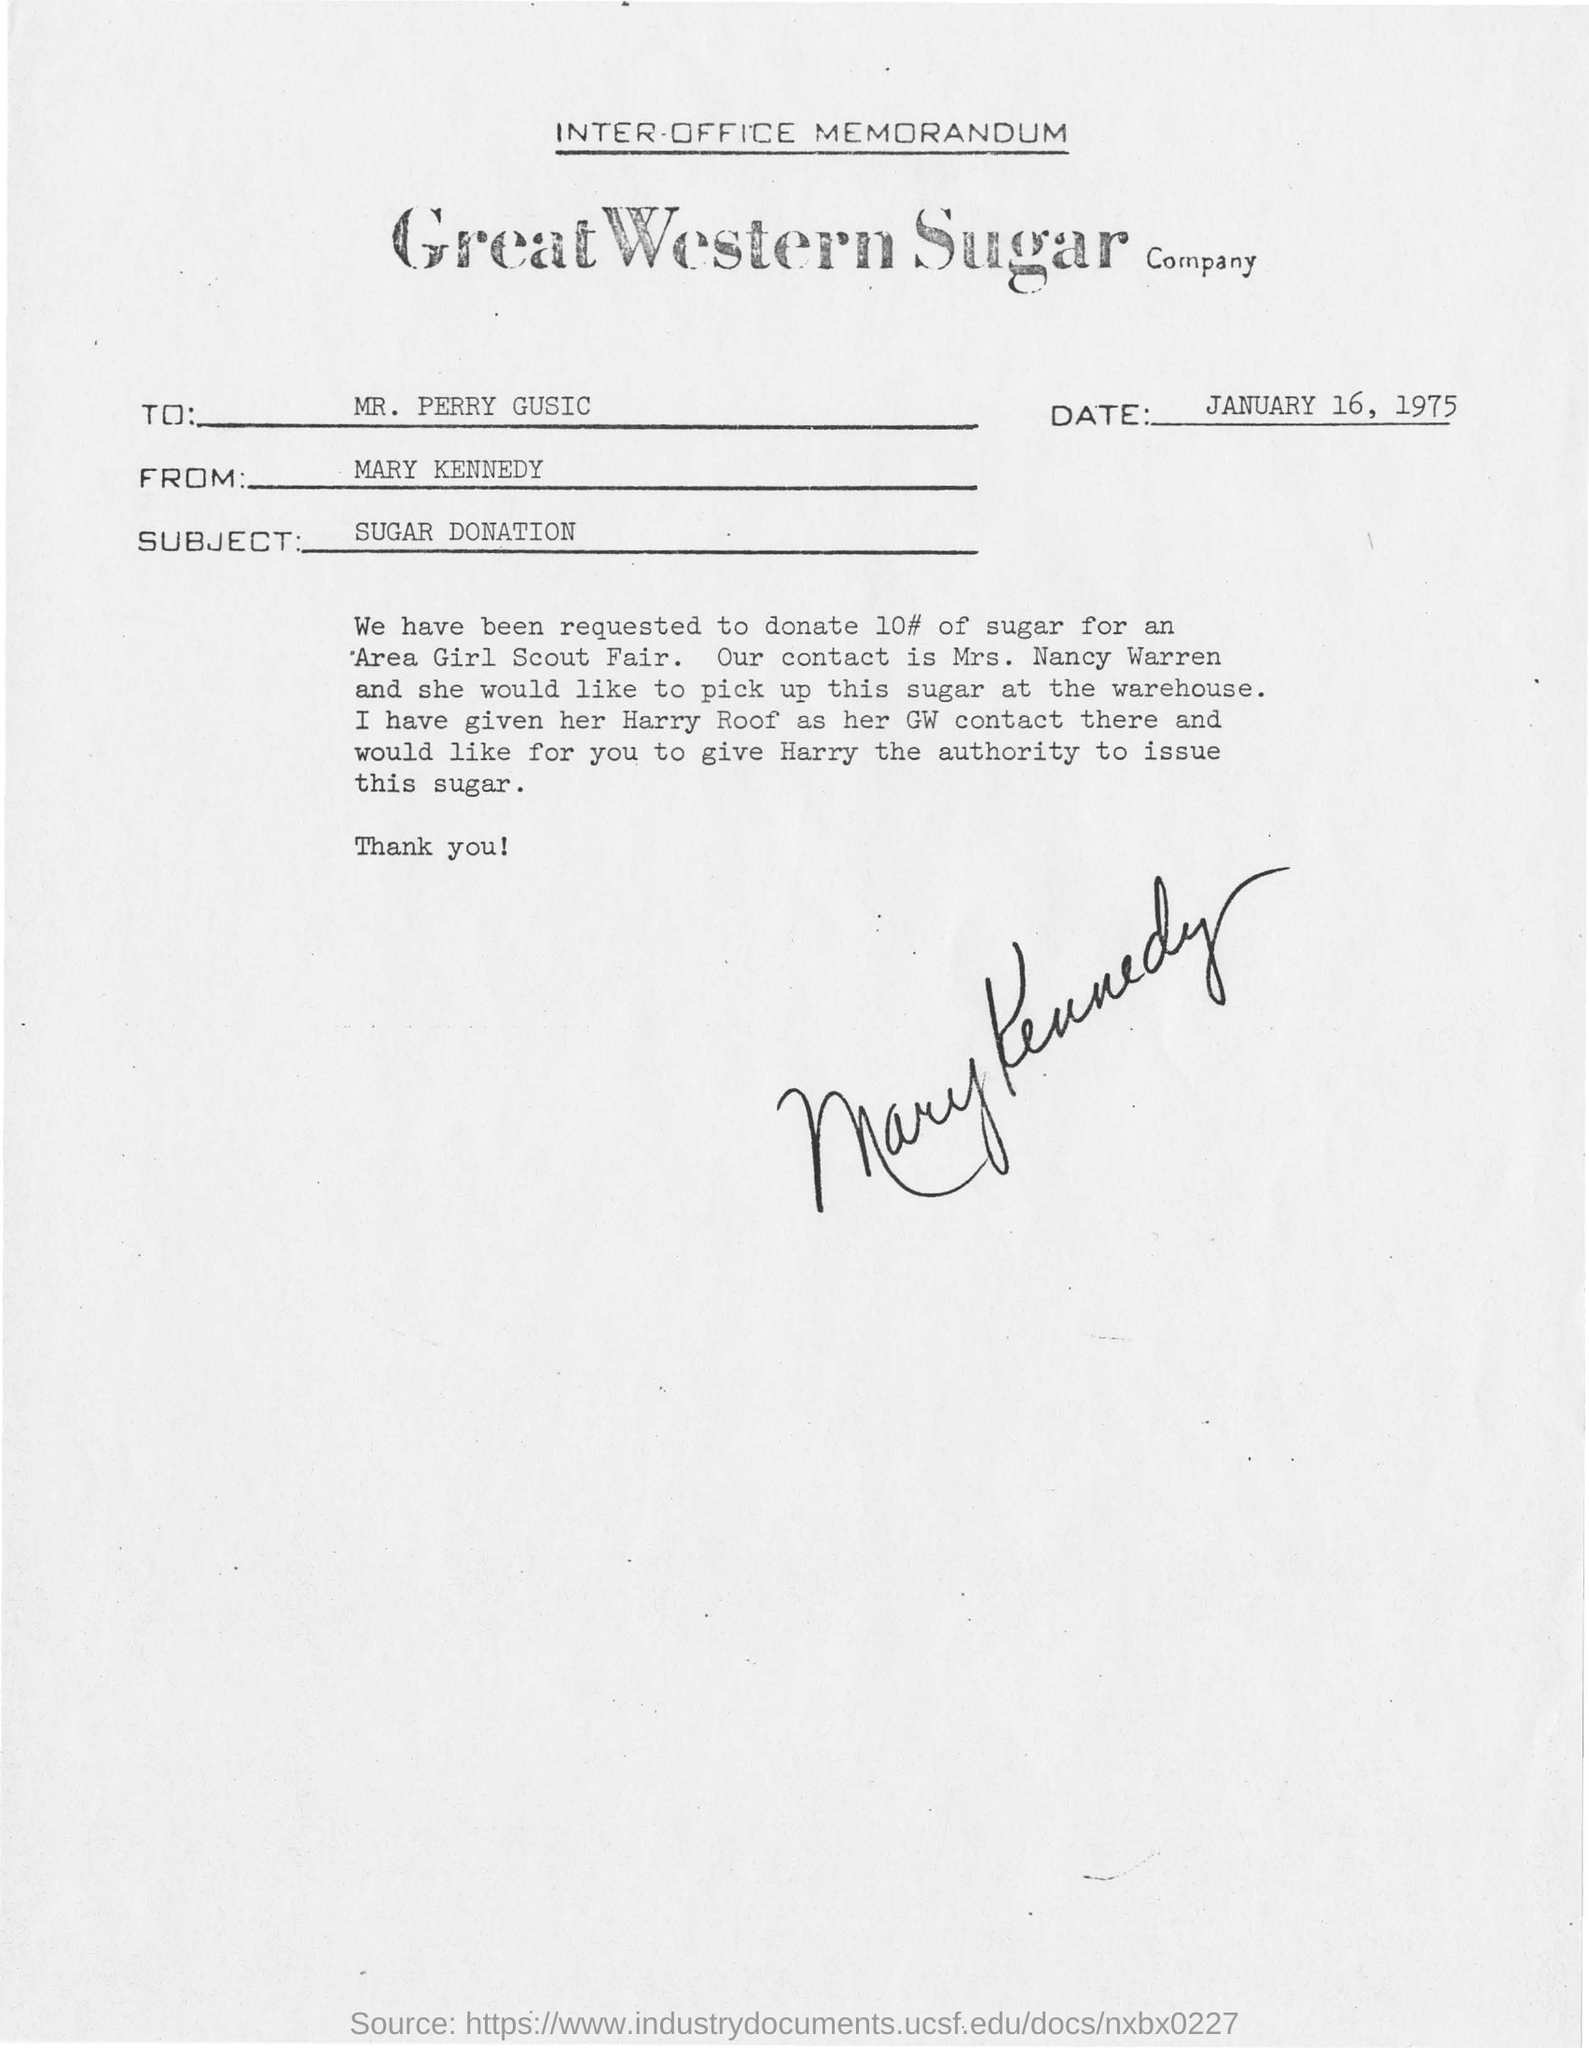Outline some significant characteristics in this image. The subject of this memorandum is the SUGAR DONATION. This memorandum is addressed to MR. PERRY GUSIC. The memorandum is from Mary Kennedy. 